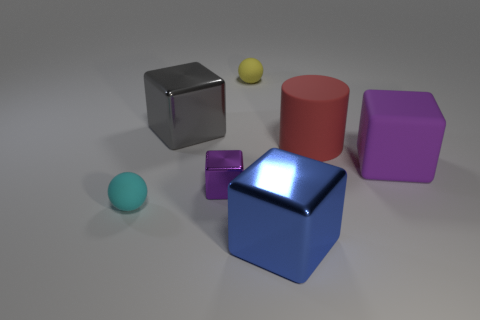Subtract all large blue metallic cubes. How many cubes are left? 3 Subtract all purple cylinders. How many purple blocks are left? 2 Subtract 2 blocks. How many blocks are left? 2 Subtract all gray blocks. How many blocks are left? 3 Add 1 yellow metal cylinders. How many objects exist? 8 Subtract all cubes. How many objects are left? 3 Subtract all green cubes. Subtract all cyan spheres. How many cubes are left? 4 Subtract all big red matte objects. Subtract all gray objects. How many objects are left? 5 Add 5 big blue cubes. How many big blue cubes are left? 6 Add 1 cyan things. How many cyan things exist? 2 